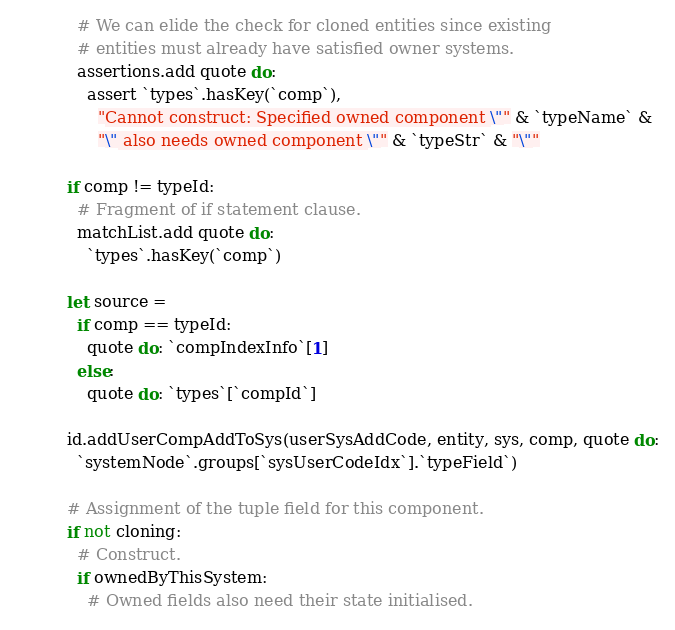<code> <loc_0><loc_0><loc_500><loc_500><_Nim_>            # We can elide the check for cloned entities since existing
            # entities must already have satisfied owner systems.
            assertions.add quote do:
              assert `types`.hasKey(`comp`),
                "Cannot construct: Specified owned component \"" & `typeName` &
                "\" also needs owned component \"" & `typeStr` & "\""
          
          if comp != typeId:
            # Fragment of if statement clause.
            matchList.add quote do:
              `types`.hasKey(`comp`)

          let source =
            if comp == typeId:
              quote do: `compIndexInfo`[1]
            else:
              quote do: `types`[`compId`]

          id.addUserCompAddToSys(userSysAddCode, entity, sys, comp, quote do:
            `systemNode`.groups[`sysUserCodeIdx`].`typeField`)

          # Assignment of the tuple field for this component.
          if not cloning:
            # Construct.
            if ownedByThisSystem:
              # Owned fields also need their state initialised.</code> 